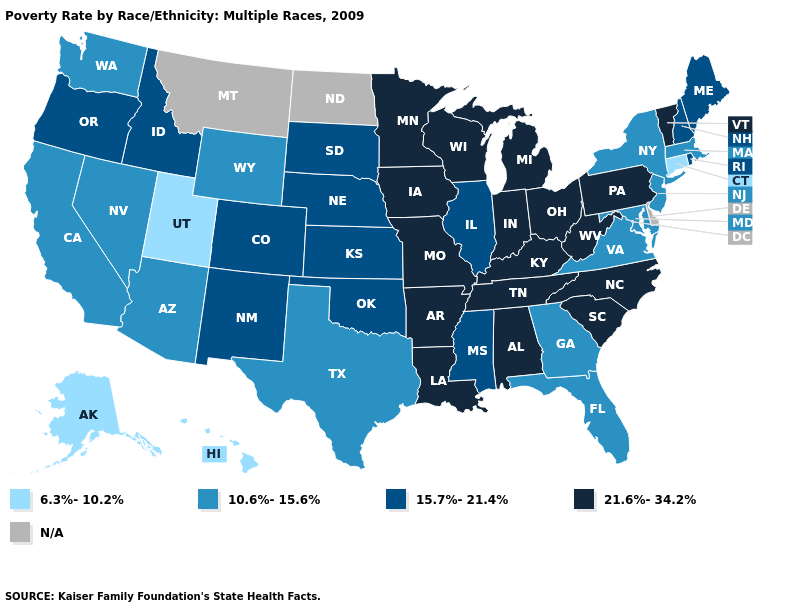Among the states that border Washington , which have the lowest value?
Write a very short answer. Idaho, Oregon. Name the states that have a value in the range N/A?
Short answer required. Delaware, Montana, North Dakota. Which states have the highest value in the USA?
Write a very short answer. Alabama, Arkansas, Indiana, Iowa, Kentucky, Louisiana, Michigan, Minnesota, Missouri, North Carolina, Ohio, Pennsylvania, South Carolina, Tennessee, Vermont, West Virginia, Wisconsin. What is the lowest value in the USA?
Concise answer only. 6.3%-10.2%. Does the first symbol in the legend represent the smallest category?
Be succinct. Yes. Name the states that have a value in the range 10.6%-15.6%?
Quick response, please. Arizona, California, Florida, Georgia, Maryland, Massachusetts, Nevada, New Jersey, New York, Texas, Virginia, Washington, Wyoming. What is the value of Arkansas?
Concise answer only. 21.6%-34.2%. What is the value of Montana?
Answer briefly. N/A. What is the lowest value in the USA?
Give a very brief answer. 6.3%-10.2%. What is the highest value in the USA?
Write a very short answer. 21.6%-34.2%. Name the states that have a value in the range 21.6%-34.2%?
Be succinct. Alabama, Arkansas, Indiana, Iowa, Kentucky, Louisiana, Michigan, Minnesota, Missouri, North Carolina, Ohio, Pennsylvania, South Carolina, Tennessee, Vermont, West Virginia, Wisconsin. Name the states that have a value in the range 10.6%-15.6%?
Be succinct. Arizona, California, Florida, Georgia, Maryland, Massachusetts, Nevada, New Jersey, New York, Texas, Virginia, Washington, Wyoming. Name the states that have a value in the range 10.6%-15.6%?
Keep it brief. Arizona, California, Florida, Georgia, Maryland, Massachusetts, Nevada, New Jersey, New York, Texas, Virginia, Washington, Wyoming. How many symbols are there in the legend?
Short answer required. 5. Does Vermont have the highest value in the Northeast?
Be succinct. Yes. 